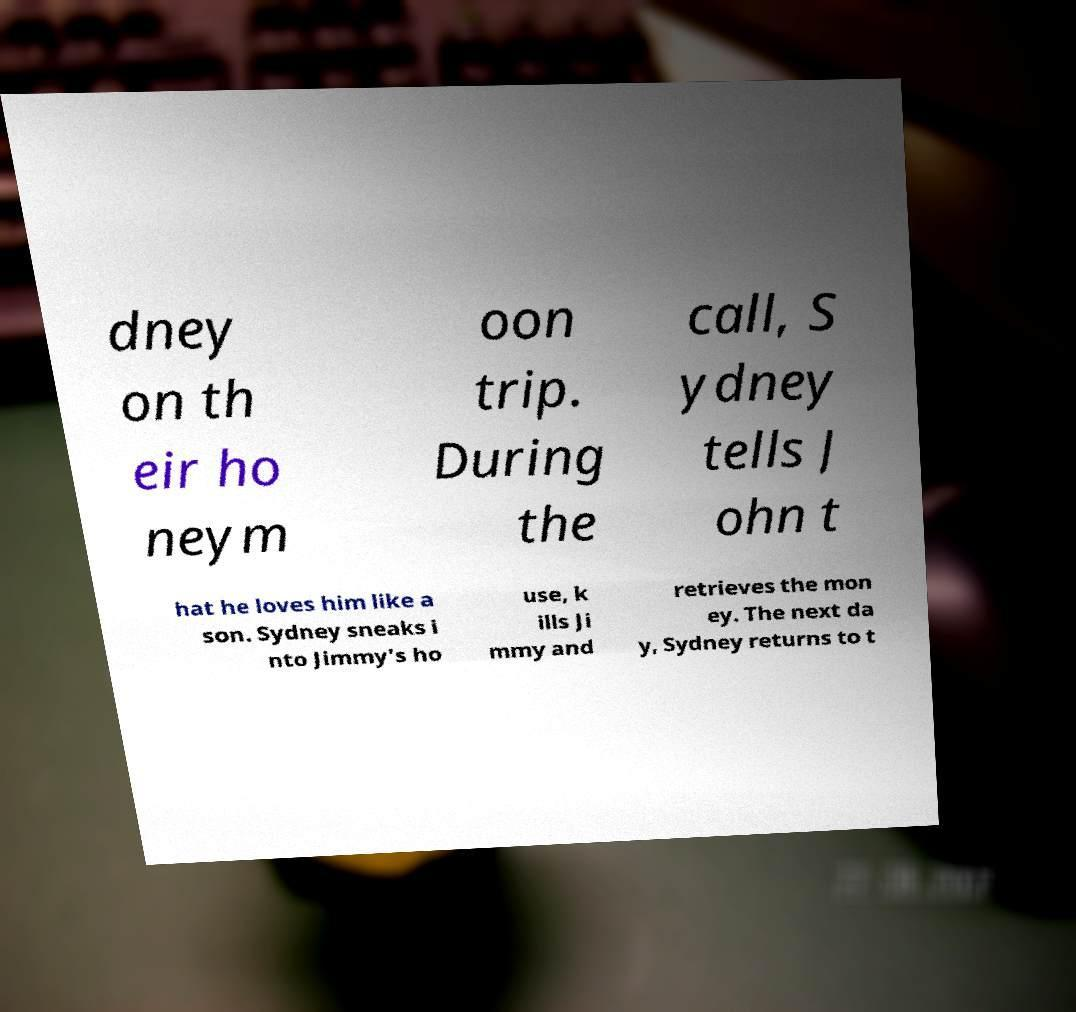Please read and relay the text visible in this image. What does it say? dney on th eir ho neym oon trip. During the call, S ydney tells J ohn t hat he loves him like a son. Sydney sneaks i nto Jimmy's ho use, k ills Ji mmy and retrieves the mon ey. The next da y, Sydney returns to t 